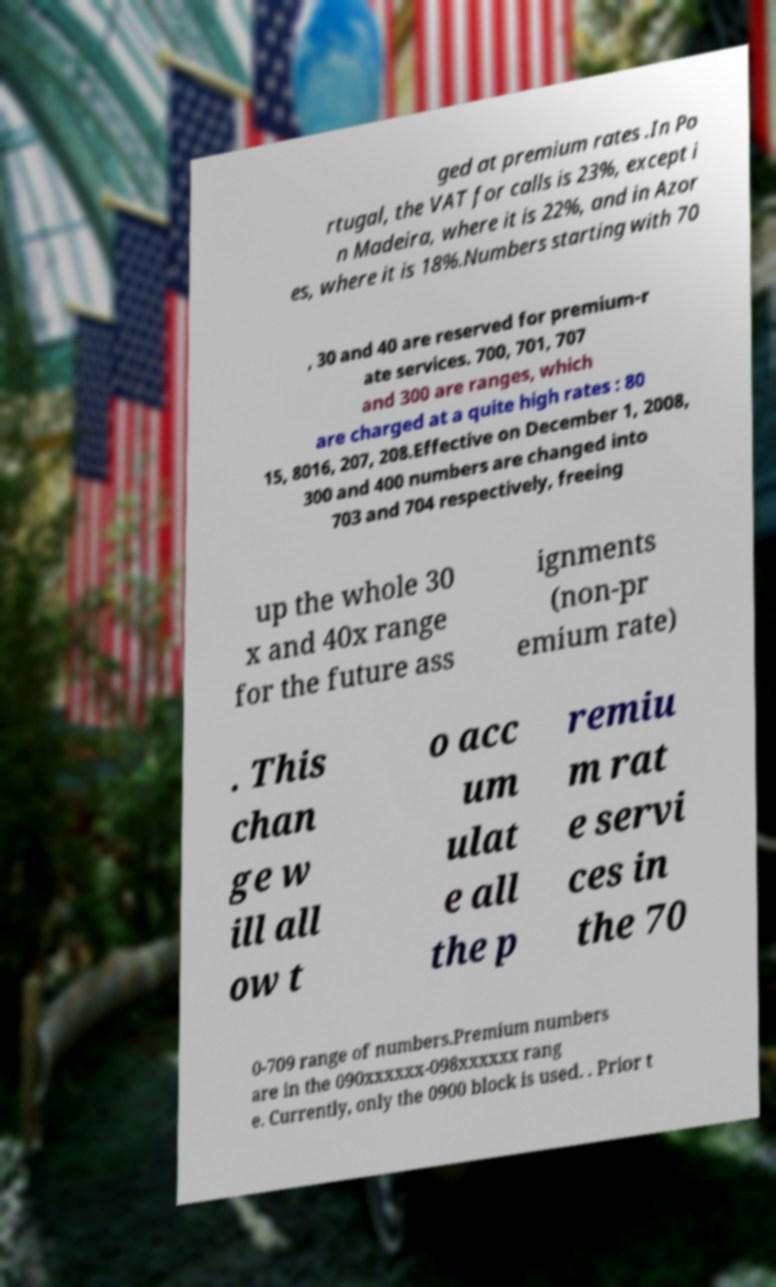I need the written content from this picture converted into text. Can you do that? ged at premium rates .In Po rtugal, the VAT for calls is 23%, except i n Madeira, where it is 22%, and in Azor es, where it is 18%.Numbers starting with 70 , 30 and 40 are reserved for premium-r ate services. 700, 701, 707 and 300 are ranges, which are charged at a quite high rates : 80 15, 8016, 207, 208.Effective on December 1, 2008, 300 and 400 numbers are changed into 703 and 704 respectively, freeing up the whole 30 x and 40x range for the future ass ignments (non-pr emium rate) . This chan ge w ill all ow t o acc um ulat e all the p remiu m rat e servi ces in the 70 0-709 range of numbers.Premium numbers are in the 090xxxxxx-098xxxxxx rang e. Currently, only the 0900 block is used. . Prior t 